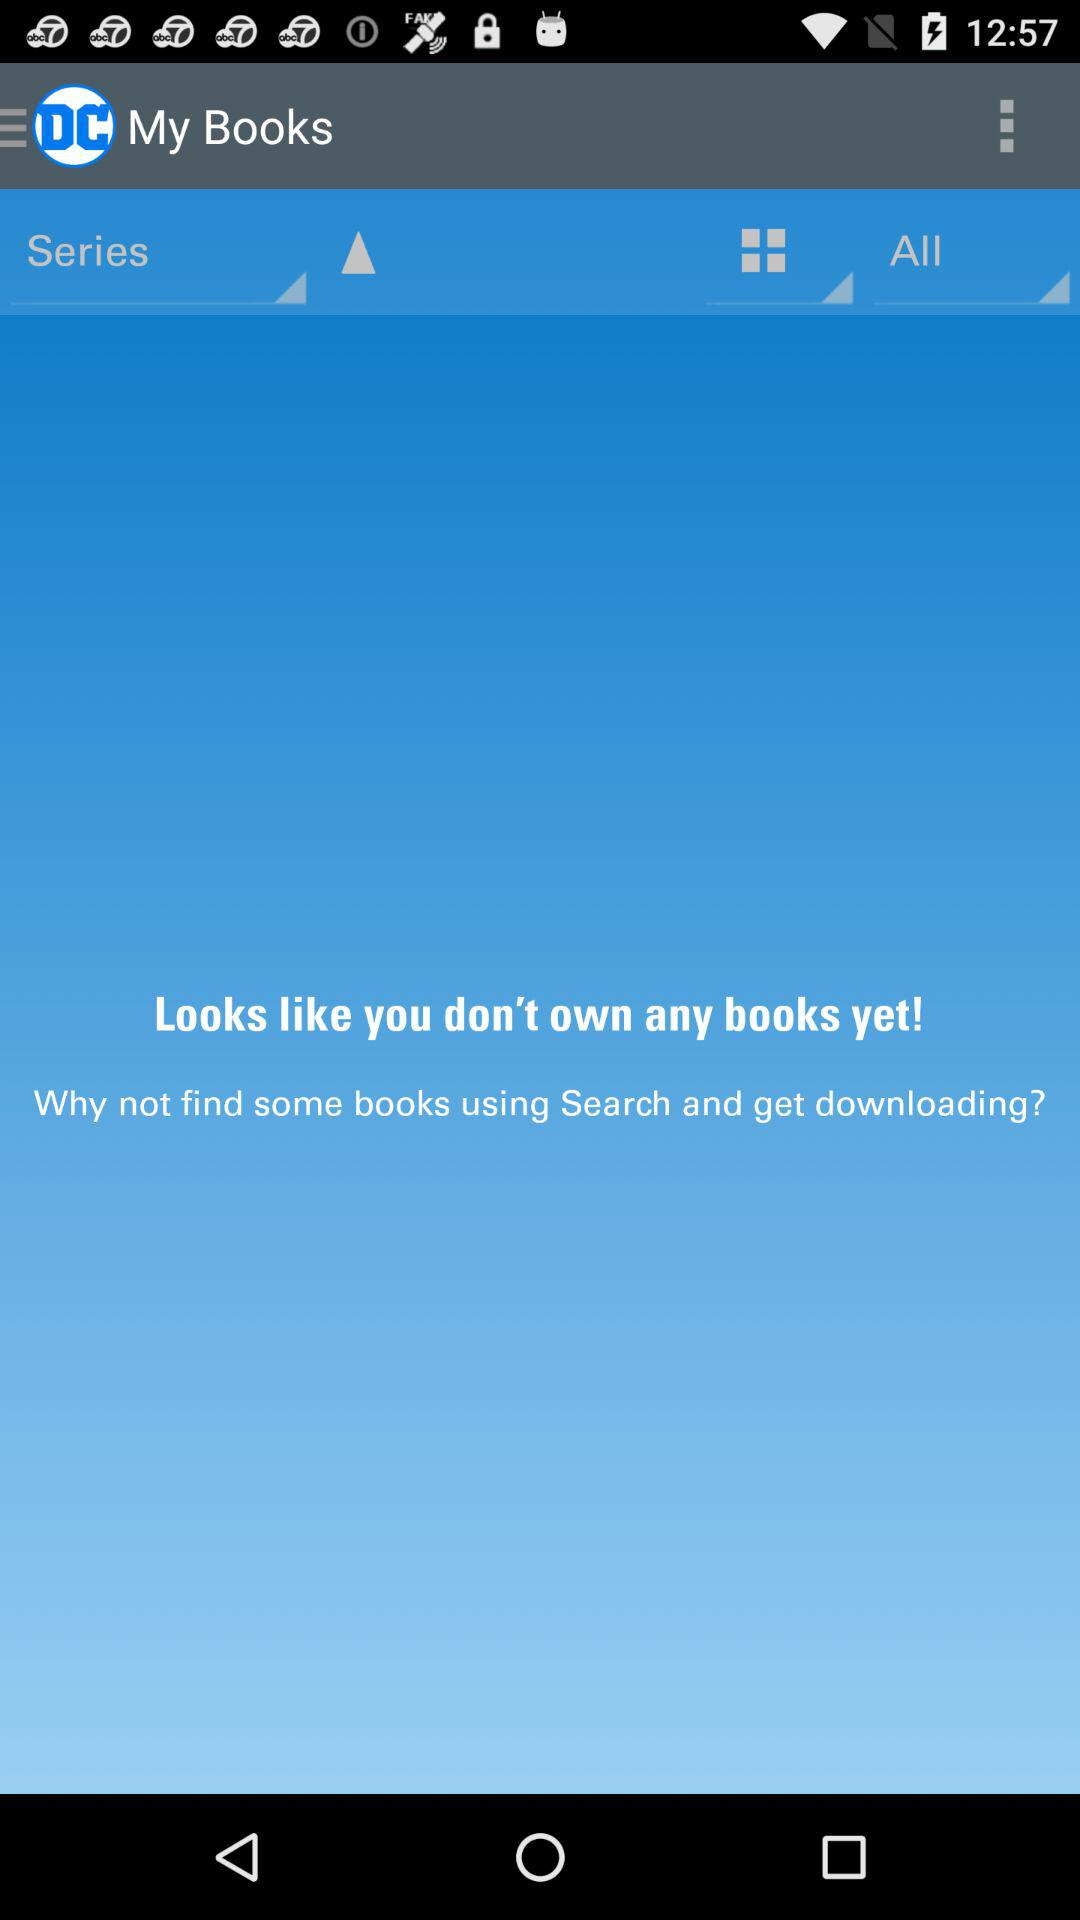How many books do I have in my library?
Answer the question using a single word or phrase. 0 